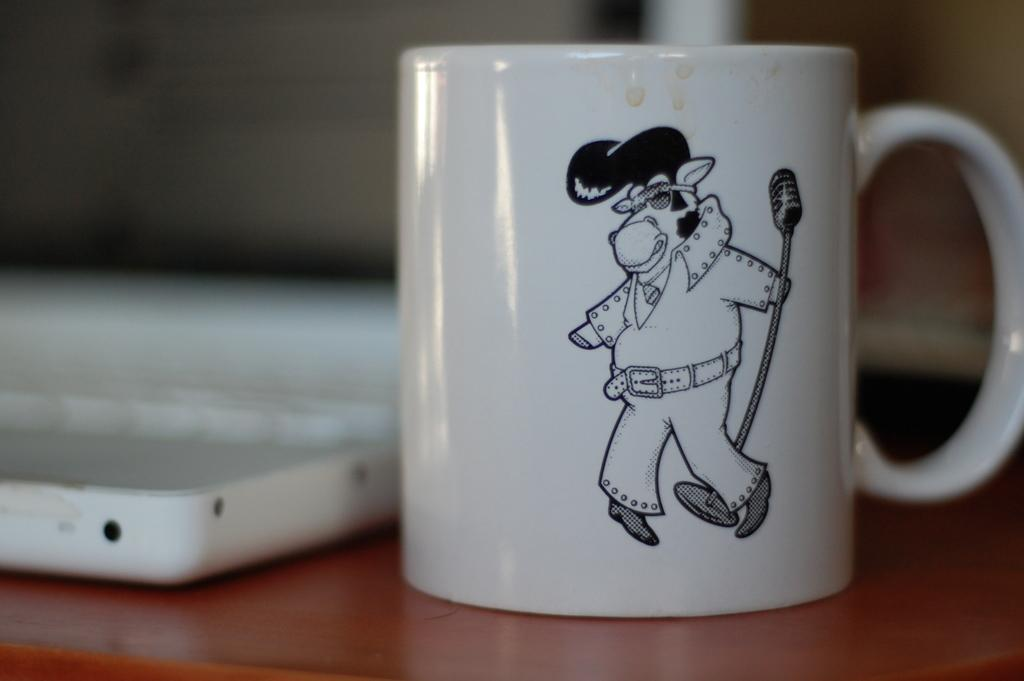What is the main subject in the center of the image? There is a mug in the center of the image. Where is the mug located? The mug is on a table. Are there any other objects on the table? Yes, there is at least one other object on the table. What type of ice can be seen melting in the mug in the image? There is no ice present in the image, and therefore no ice can be seen melting in the mug. 